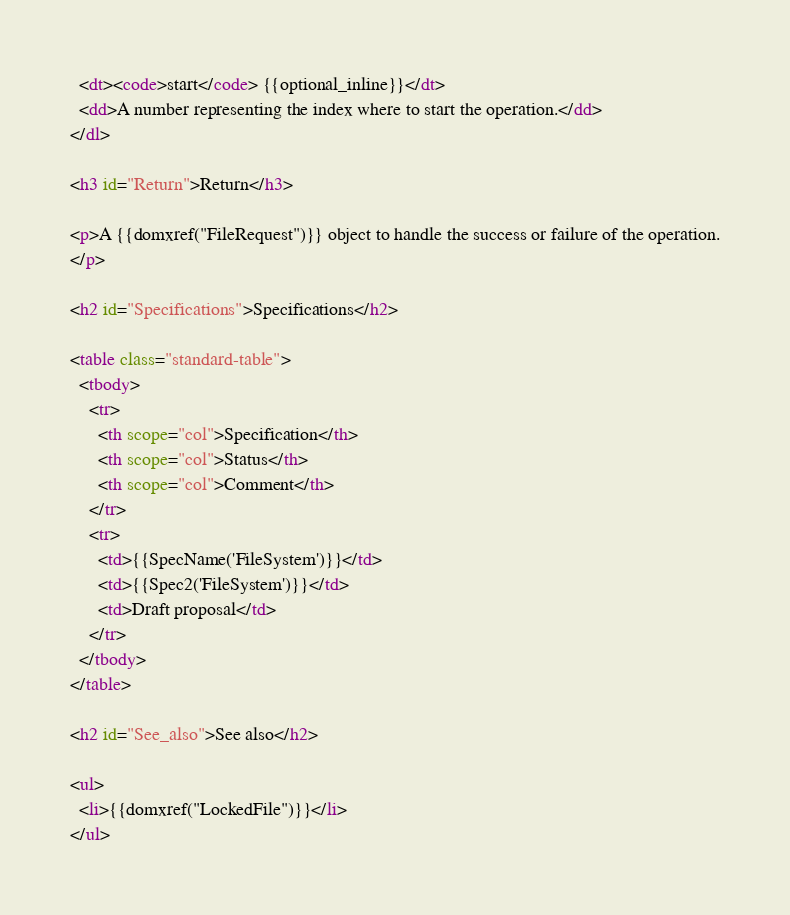Convert code to text. <code><loc_0><loc_0><loc_500><loc_500><_HTML_>  <dt><code>start</code> {{optional_inline}}</dt>
  <dd>A number representing the index where to start the operation.</dd>
</dl>

<h3 id="Return">Return</h3>

<p>A {{domxref("FileRequest")}} object to handle the success or failure of the operation.
</p>

<h2 id="Specifications">Specifications</h2>

<table class="standard-table">
  <tbody>
    <tr>
      <th scope="col">Specification</th>
      <th scope="col">Status</th>
      <th scope="col">Comment</th>
    </tr>
    <tr>
      <td>{{SpecName('FileSystem')}}</td>
      <td>{{Spec2('FileSystem')}}</td>
      <td>Draft proposal</td>
    </tr>
  </tbody>
</table>

<h2 id="See_also">See also</h2>

<ul>
  <li>{{domxref("LockedFile")}}</li>
</ul>
</code> 